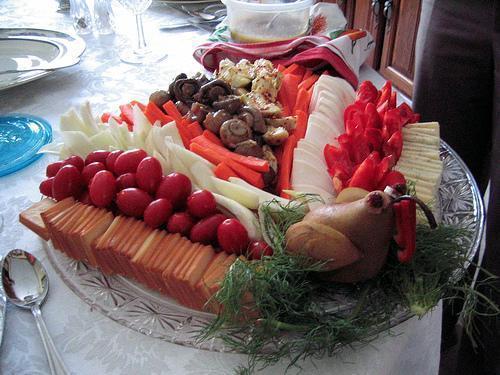How many spoons are there?
Give a very brief answer. 1. 